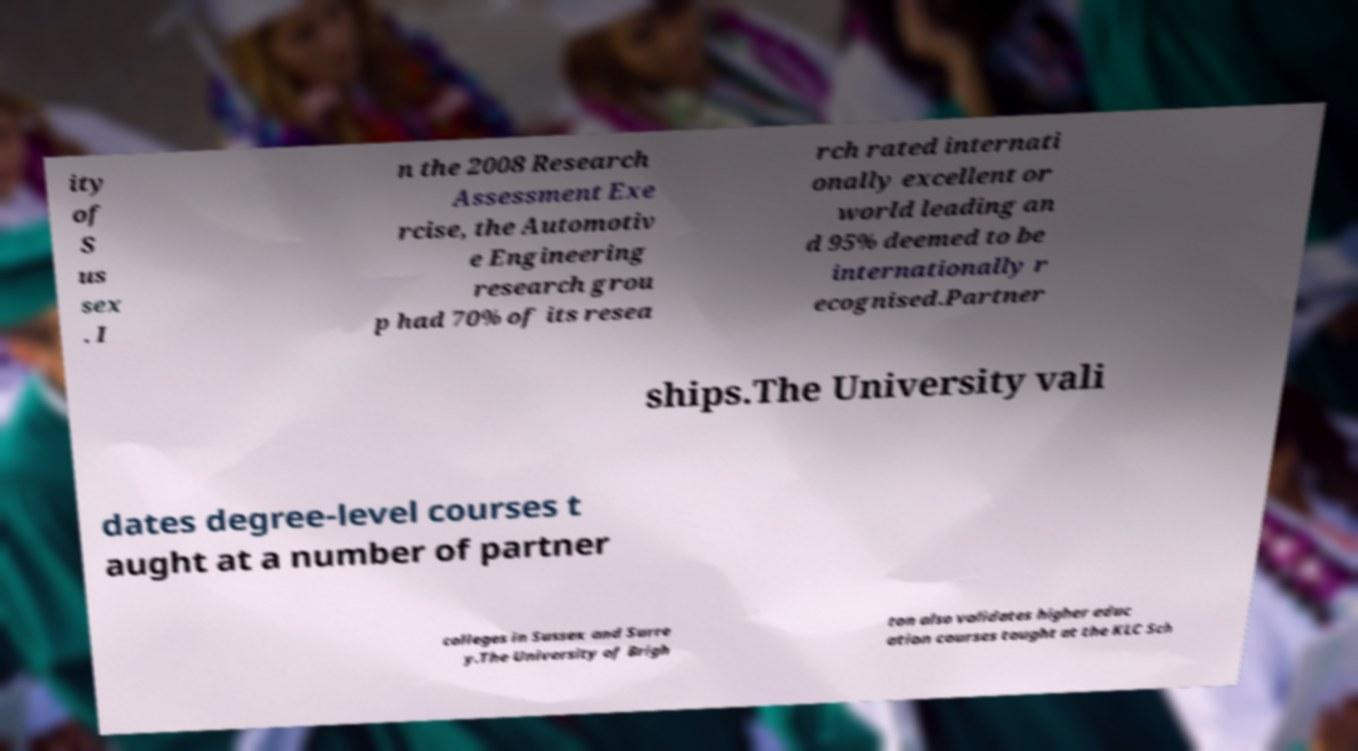Can you accurately transcribe the text from the provided image for me? ity of S us sex . I n the 2008 Research Assessment Exe rcise, the Automotiv e Engineering research grou p had 70% of its resea rch rated internati onally excellent or world leading an d 95% deemed to be internationally r ecognised.Partner ships.The University vali dates degree-level courses t aught at a number of partner colleges in Sussex and Surre y.The University of Brigh ton also validates higher educ ation courses taught at the KLC Sch 